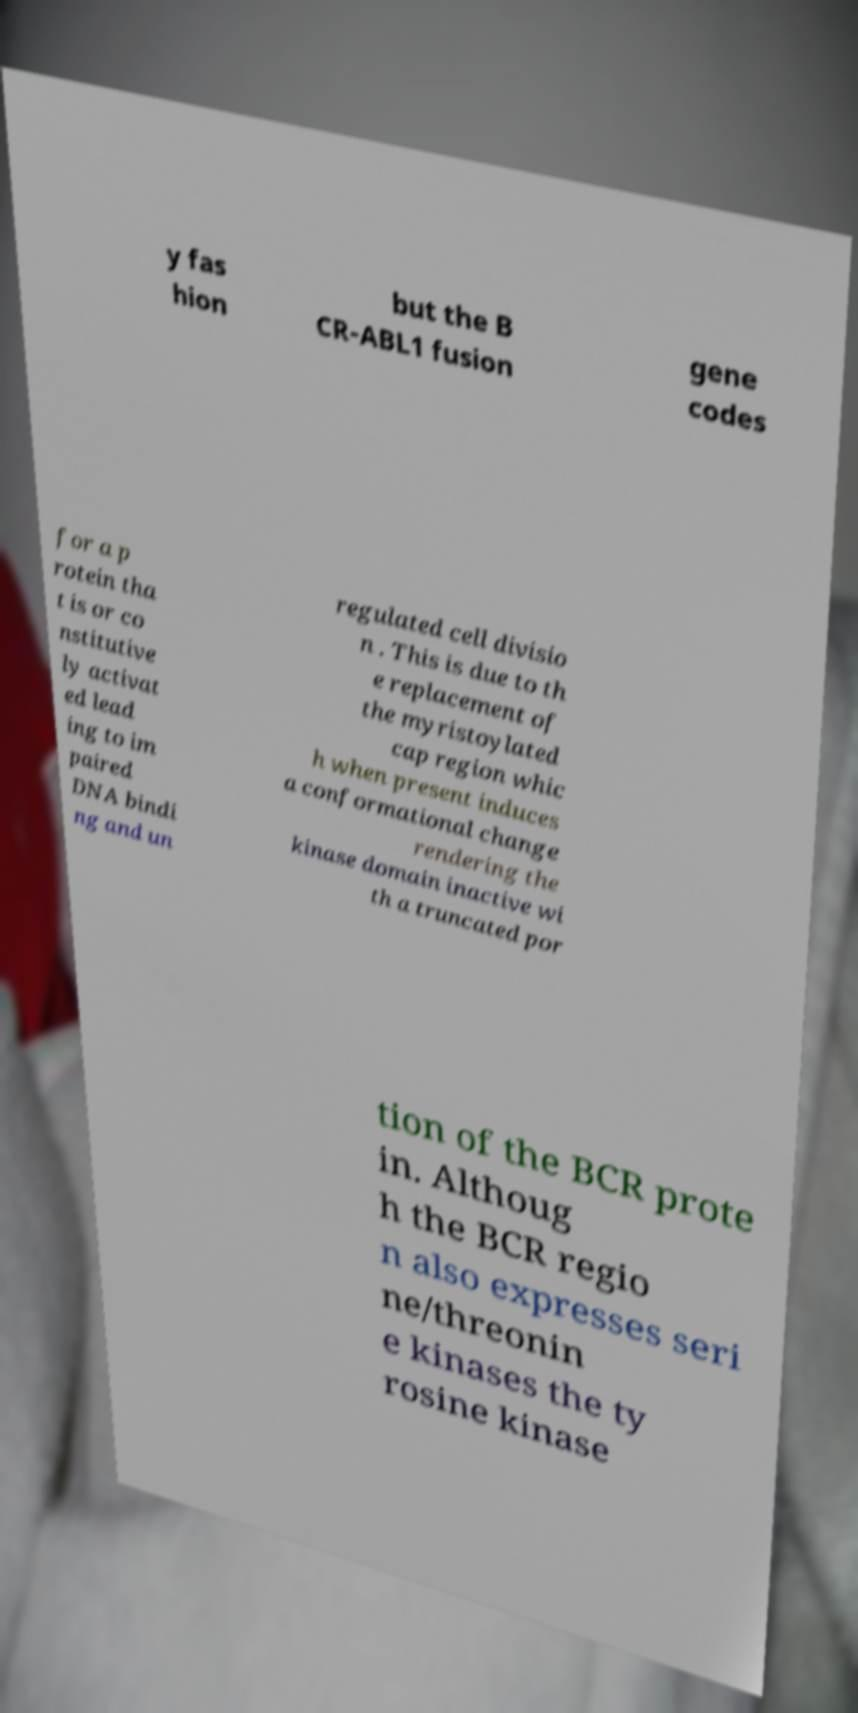Could you extract and type out the text from this image? y fas hion but the B CR-ABL1 fusion gene codes for a p rotein tha t is or co nstitutive ly activat ed lead ing to im paired DNA bindi ng and un regulated cell divisio n . This is due to th e replacement of the myristoylated cap region whic h when present induces a conformational change rendering the kinase domain inactive wi th a truncated por tion of the BCR prote in. Althoug h the BCR regio n also expresses seri ne/threonin e kinases the ty rosine kinase 